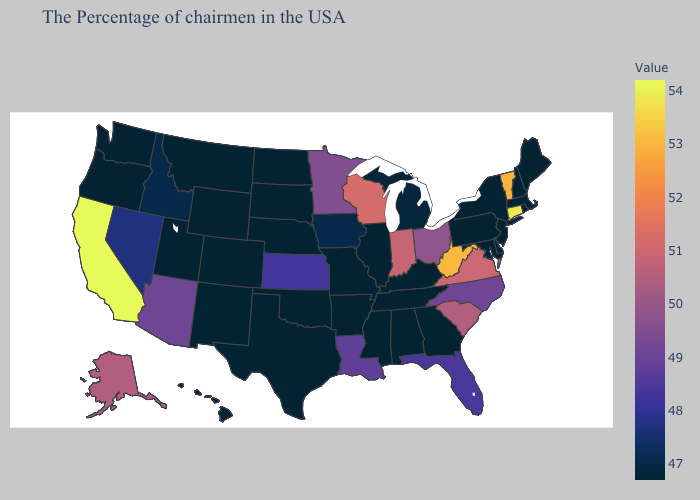Does Minnesota have a lower value than West Virginia?
Answer briefly. Yes. Does Iowa have the lowest value in the USA?
Quick response, please. No. Does Utah have a lower value than Alaska?
Give a very brief answer. Yes. Does Alaska have a higher value than California?
Concise answer only. No. Does New Hampshire have the highest value in the USA?
Be succinct. No. Among the states that border Washington , does Idaho have the lowest value?
Give a very brief answer. No. Which states hav the highest value in the South?
Short answer required. West Virginia. Does Florida have a higher value than Minnesota?
Give a very brief answer. No. 